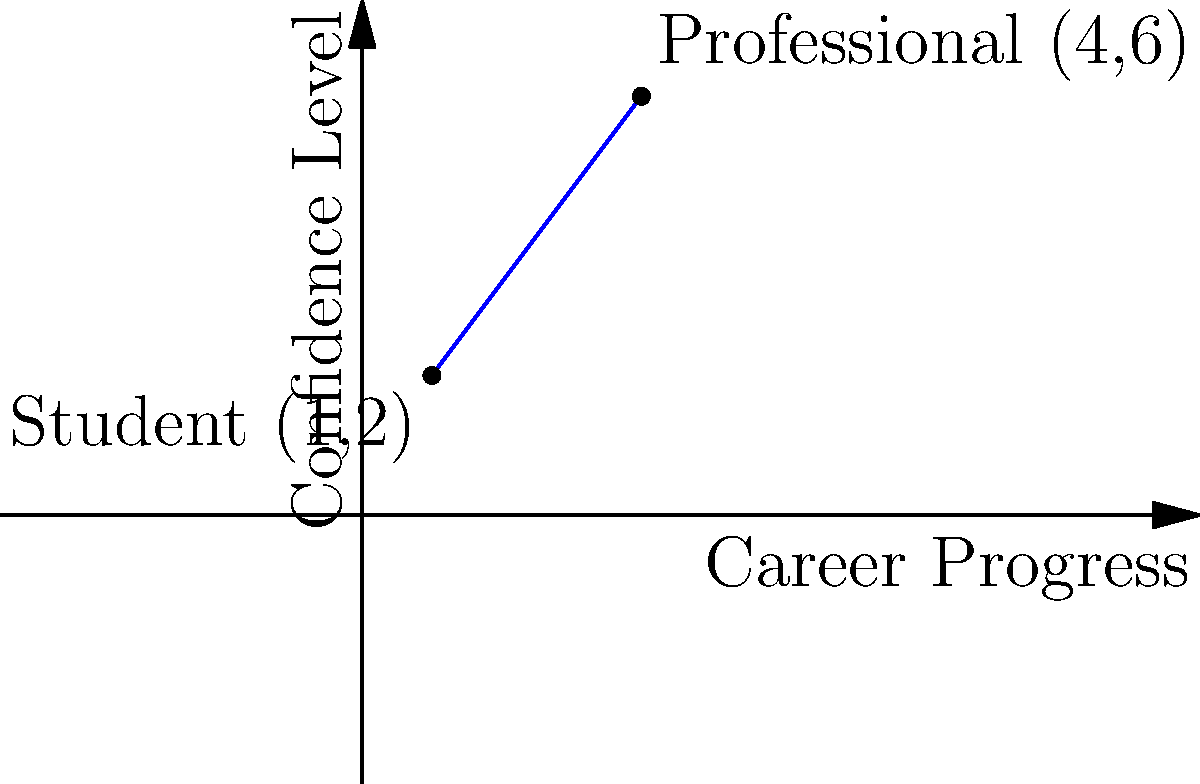In a coordinate system representing career progress (x-axis) and confidence level (y-axis), a person's journey from a shy student to a confident businesswoman is plotted. The student's initial position is at (1,2), and the professional's final position is at (4,6). What is the slope of the line connecting these two points, representing the rate of confidence growth relative to career progress? To find the slope of the line connecting the two points, we'll use the slope formula:

$$ \text{Slope} = \frac{y_2 - y_1}{x_2 - x_1} $$

Where $(x_1, y_1)$ is the initial point (student) and $(x_2, y_2)$ is the final point (professional).

Step 1: Identify the coordinates
- Student (initial point): $(x_1, y_1) = (1, 2)$
- Professional (final point): $(x_2, y_2) = (4, 6)$

Step 2: Apply the slope formula
$$ \text{Slope} = \frac{6 - 2}{4 - 1} = \frac{4}{3} $$

Step 3: Simplify the fraction
The slope $\frac{4}{3}$ is already in its simplest form.

Therefore, the slope of the line representing the rate of confidence growth relative to career progress is $\frac{4}{3}$.
Answer: $\frac{4}{3}$ 